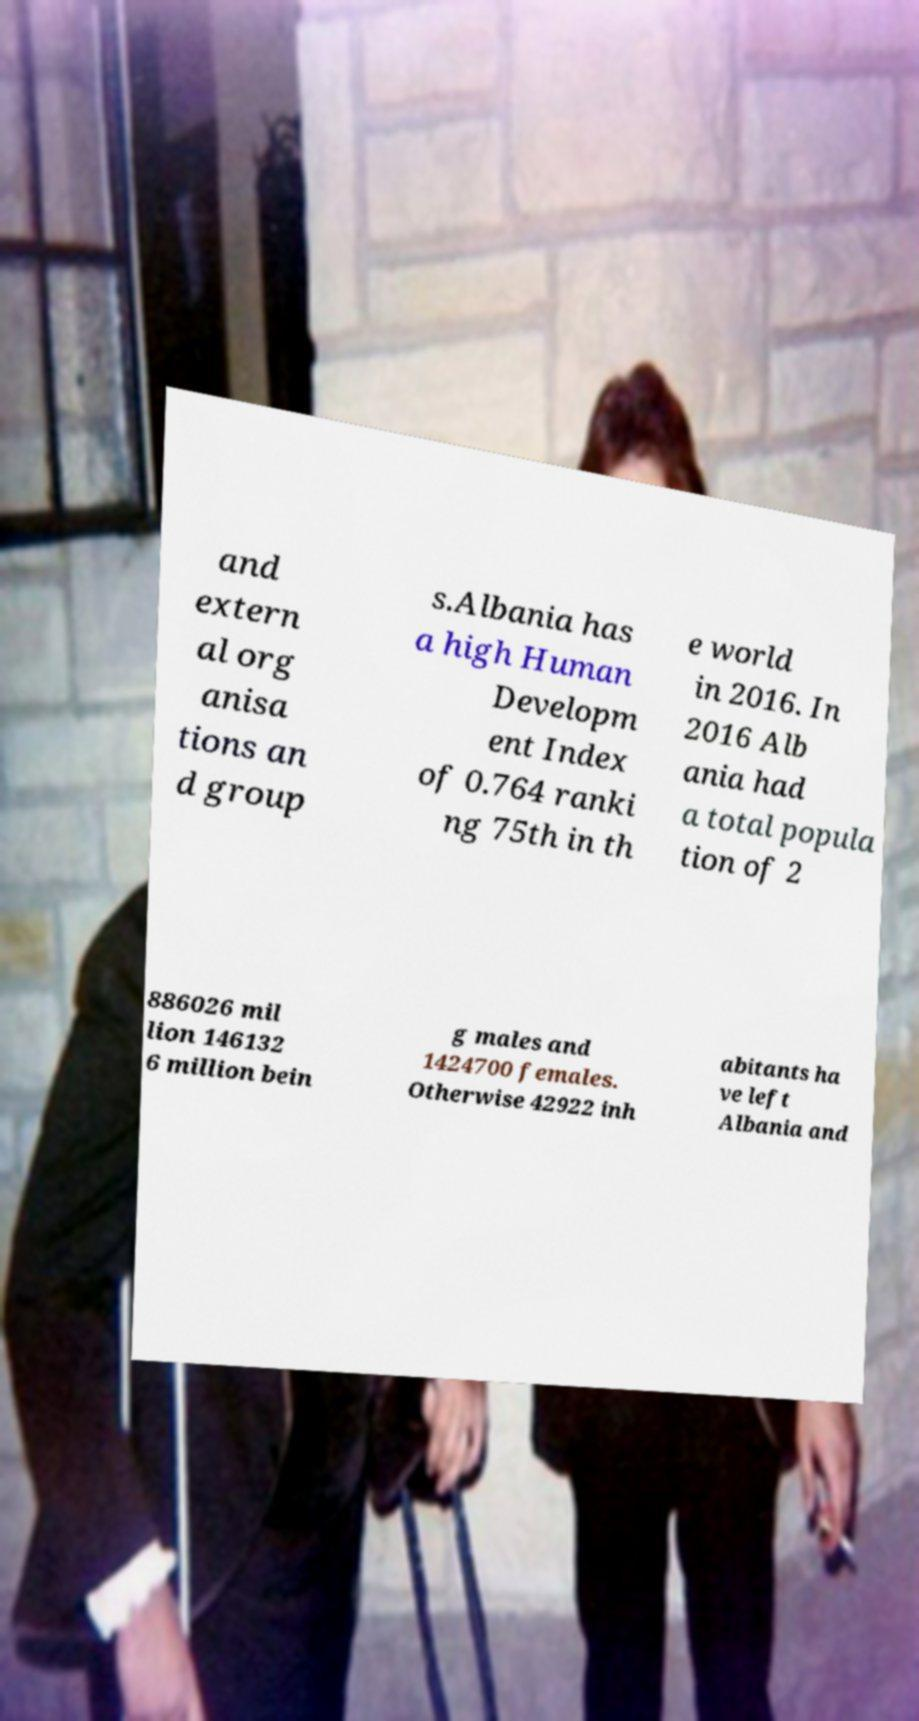Can you read and provide the text displayed in the image?This photo seems to have some interesting text. Can you extract and type it out for me? and extern al org anisa tions an d group s.Albania has a high Human Developm ent Index of 0.764 ranki ng 75th in th e world in 2016. In 2016 Alb ania had a total popula tion of 2 886026 mil lion 146132 6 million bein g males and 1424700 females. Otherwise 42922 inh abitants ha ve left Albania and 